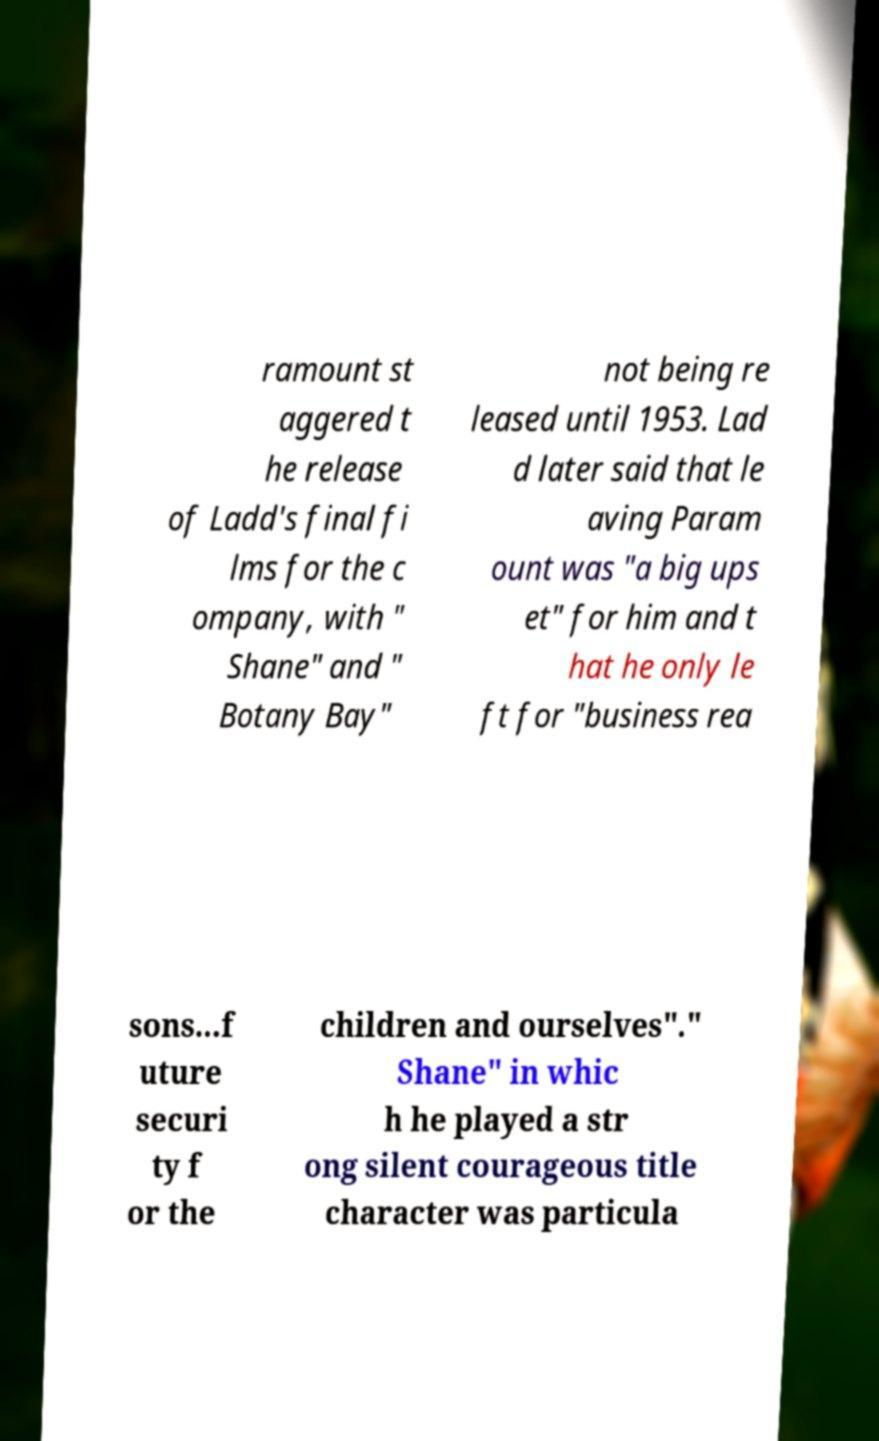For documentation purposes, I need the text within this image transcribed. Could you provide that? ramount st aggered t he release of Ladd's final fi lms for the c ompany, with " Shane" and " Botany Bay" not being re leased until 1953. Lad d later said that le aving Param ount was "a big ups et" for him and t hat he only le ft for "business rea sons...f uture securi ty f or the children and ourselves"." Shane" in whic h he played a str ong silent courageous title character was particula 